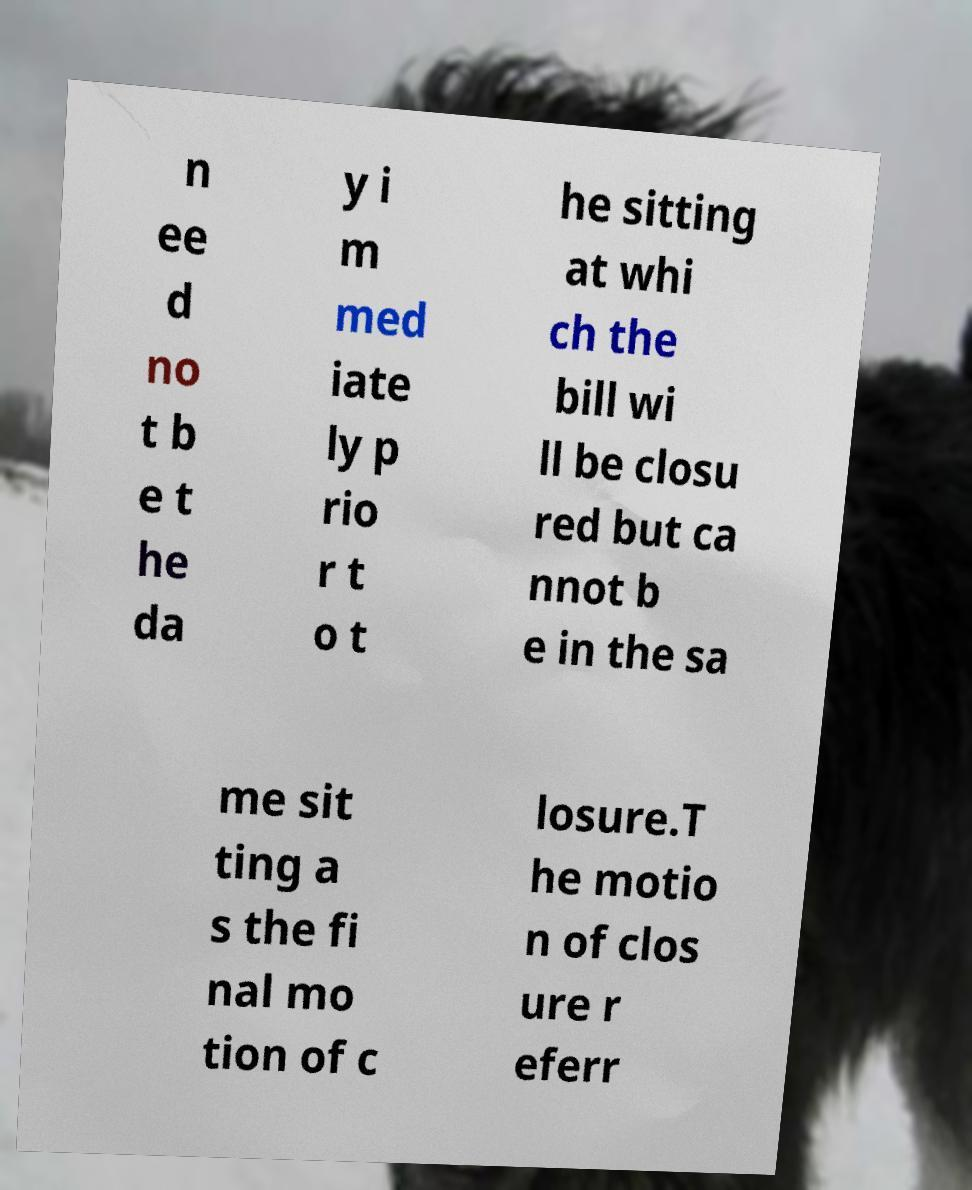Could you extract and type out the text from this image? n ee d no t b e t he da y i m med iate ly p rio r t o t he sitting at whi ch the bill wi ll be closu red but ca nnot b e in the sa me sit ting a s the fi nal mo tion of c losure.T he motio n of clos ure r eferr 